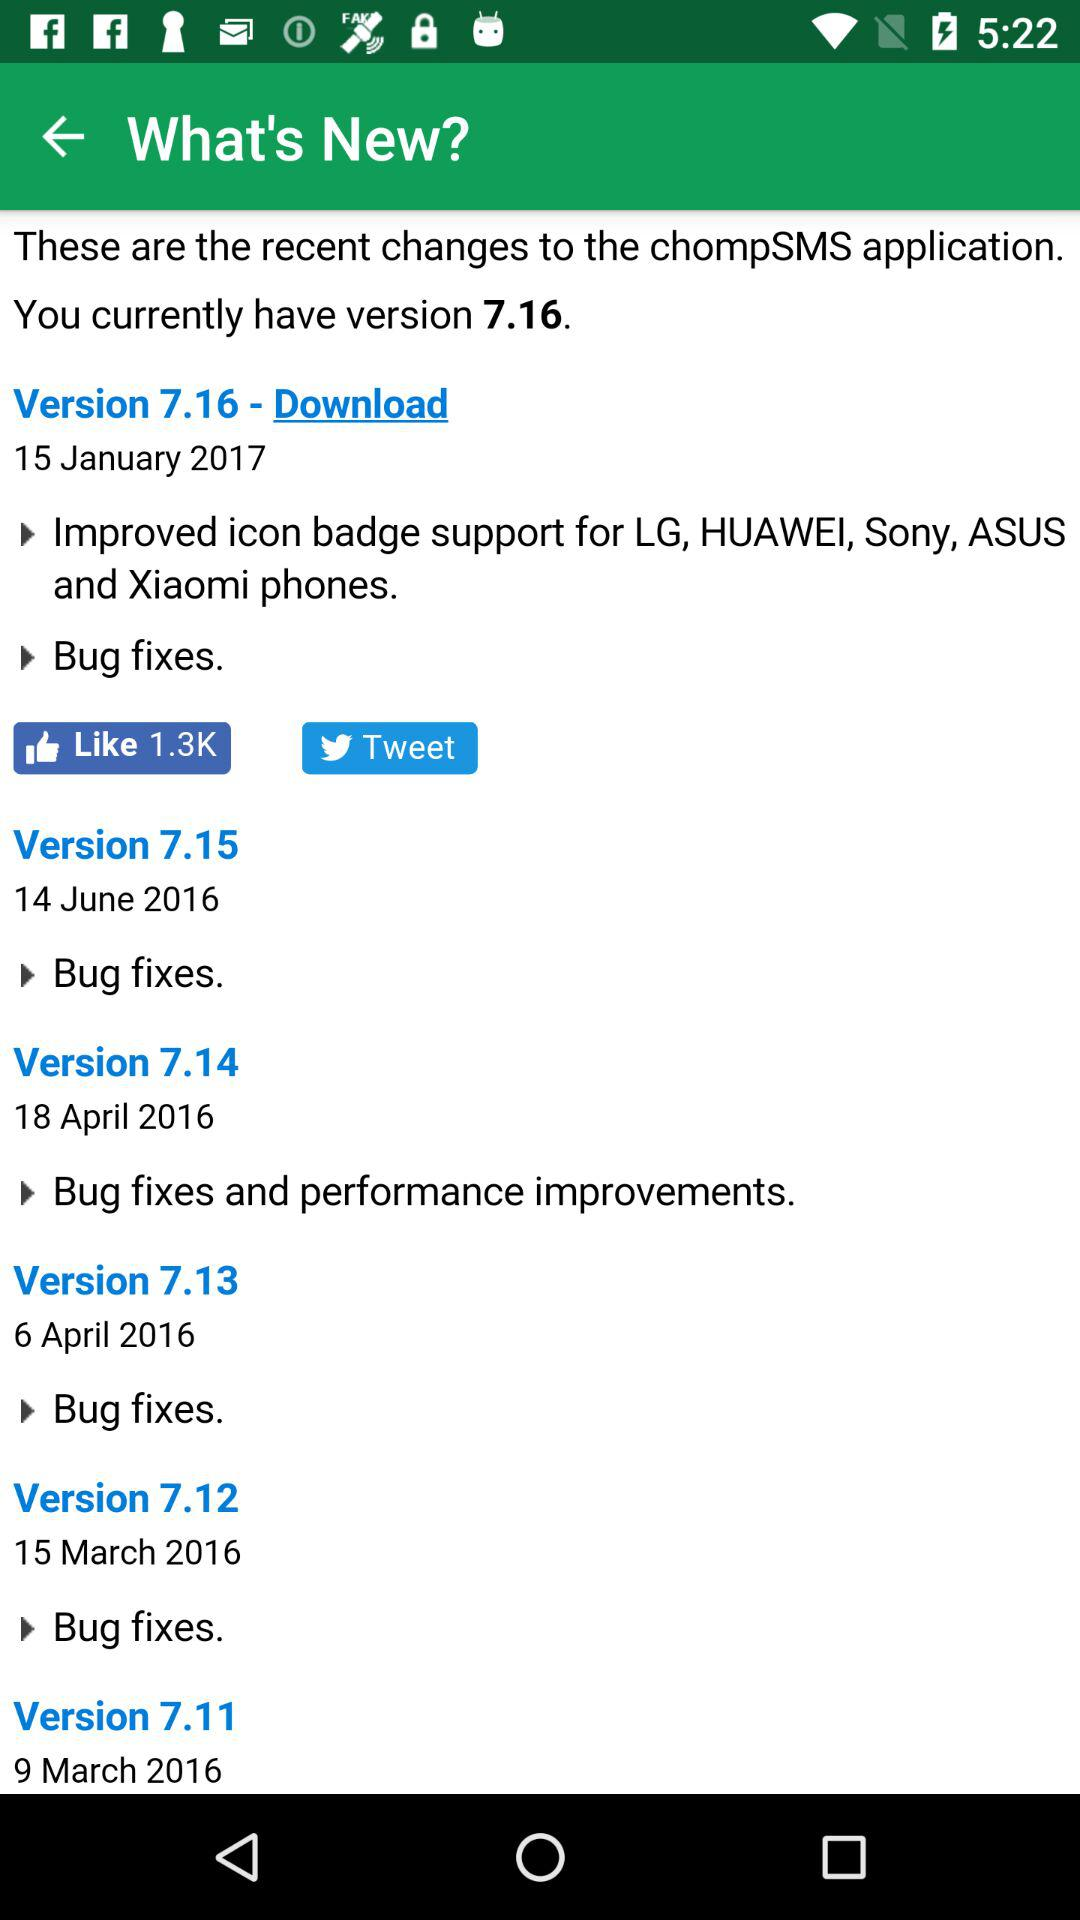Which version was released on March 9, 2016? The version that was released on March 9, 2016 was 7.11. 